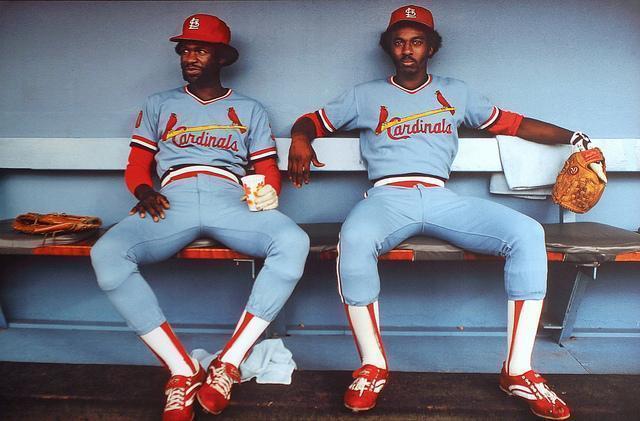Who played for this team?
Indicate the correct response and explain using: 'Answer: answer
Rationale: rationale.'
Options: Mark mcgwire, barry bonds, alex rodriguez, jose canseco. Answer: mark mcgwire.
Rationale: Mark mcgwire is known for playing for the cardinals. he is famous for his homeruns. 